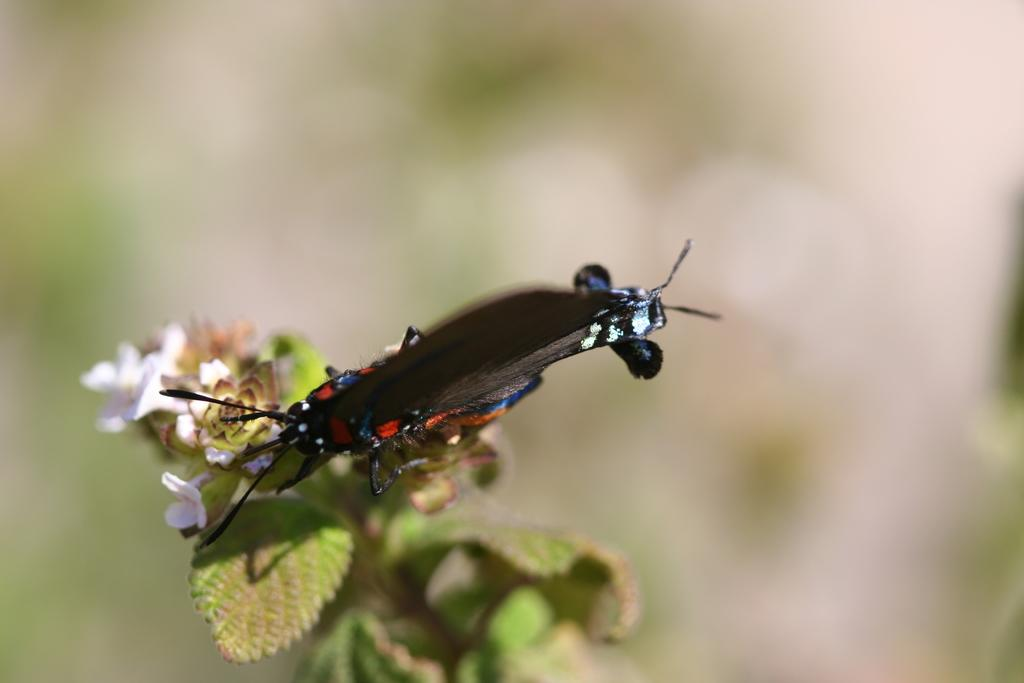What is present in the image? There is an insect in the image. Where is the insect located? The insect is on a plant. What type of coil is being used by the insect to climb the plant? There is no coil present in the image; the insect is simply on the plant. Who is the creator of the insect in the image? The image does not provide information about the insect's creator. 